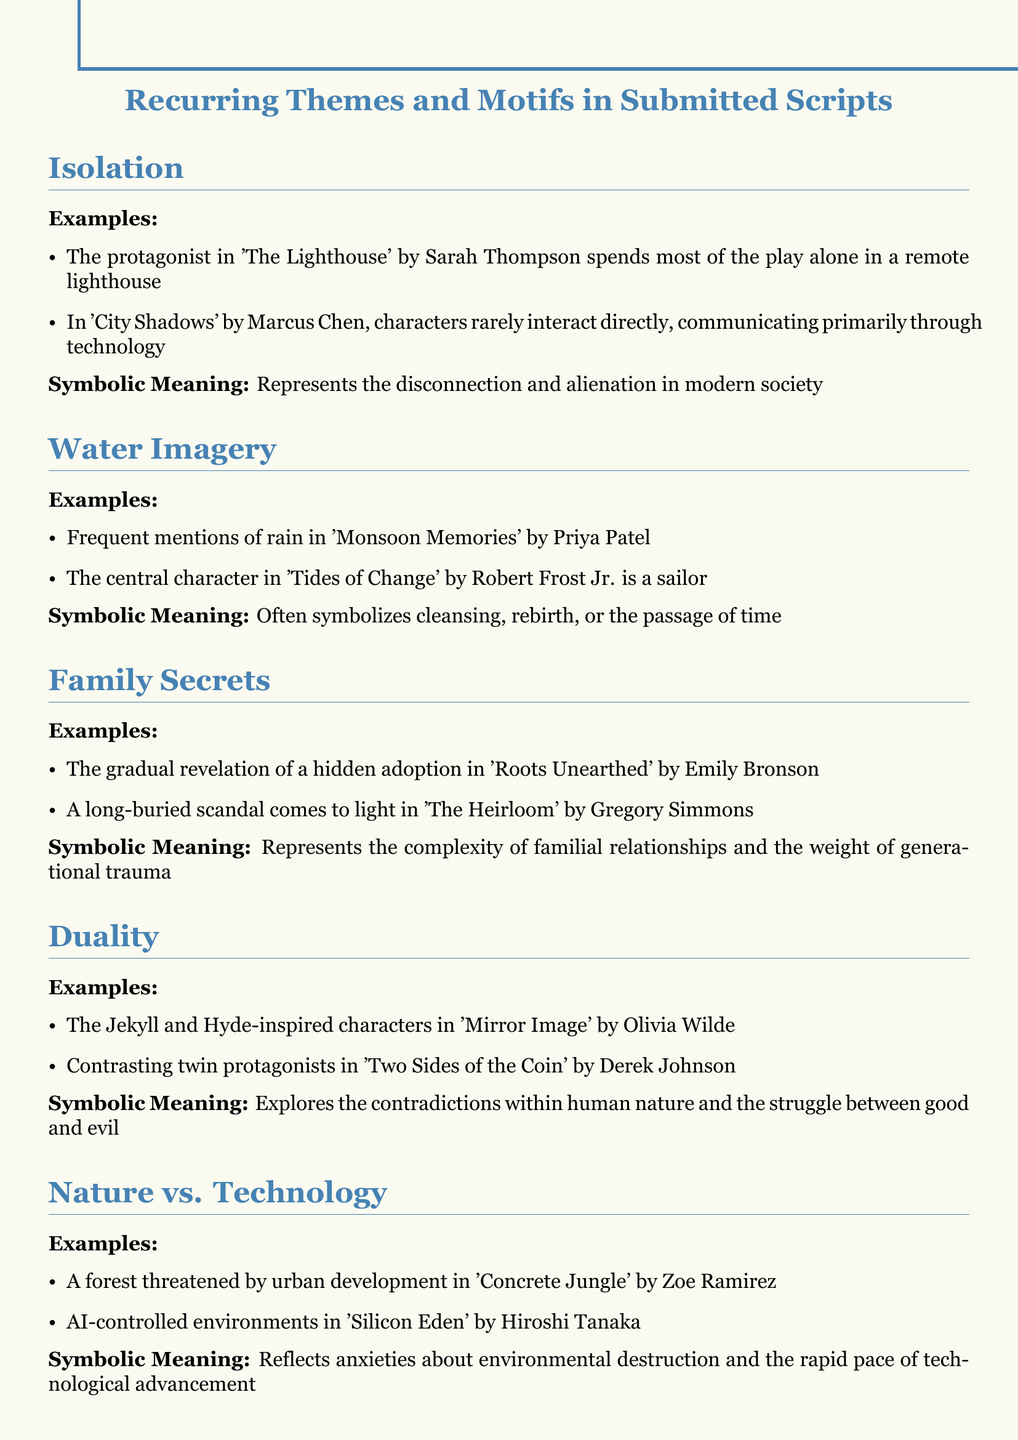What is the theme associated with disconnection and alienation? The document identifies "Isolation" as a recurring theme that symbolizes disconnection and alienation in modern society.
Answer: Isolation Who wrote 'City Shadows'? The play 'City Shadows' is authored by Marcus Chen, as mentioned in the examples of the theme "Isolation."
Answer: Marcus Chen What is a potential meaning of water imagery in the scripts? The document states that water imagery often symbolizes cleansing, rebirth, or the passage of time.
Answer: Cleansing, rebirth, or the passage of time Which theme involves the complexities of familial relationships? The theme "Family secrets" represents the complexity of familial relationships and the weight of generational trauma.
Answer: Family secrets In which script does a hidden adoption get revealed? The hidden adoption is gradually revealed in 'Roots Unearthed', which is cited under the theme "Family secrets."
Answer: Roots Unearthed What type of characters are present in 'Mirror Image'? The characters in 'Mirror Image' are inspired by Jekyll and Hyde, as mentioned in the theme "Duality."
Answer: Jekyll and Hyde-inspired characters What does the theme "Nature vs. Technology" reflect anxieties about? This theme reflects anxieties about environmental destruction and the rapid pace of technological advancement.
Answer: Environmental destruction and technological advancement How many examples are given for the theme of "Isolation"? There are two examples provided under the theme "Isolation."
Answer: Two What motif is represented by the opposing forces within human nature? The motif of "Duality" explores the contradictions within human nature and the struggle between good and evil.
Answer: Duality 